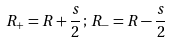<formula> <loc_0><loc_0><loc_500><loc_500>R _ { + } = R + \frac { s } { 2 } \, ; \, R _ { - } = R - \frac { s } { 2 }</formula> 